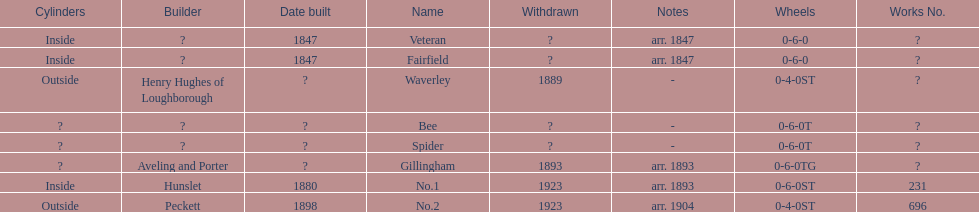Did fairfield or waverley have inside cylinders? Fairfield. 